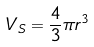Convert formula to latex. <formula><loc_0><loc_0><loc_500><loc_500>V _ { S } = \frac { 4 } { 3 } \pi r ^ { 3 }</formula> 